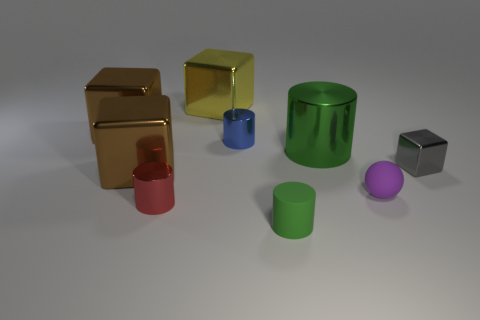There is a blue cylinder that is the same size as the gray object; what material is it?
Provide a short and direct response. Metal. There is a thing that is to the left of the tiny red cylinder and in front of the blue metal cylinder; what shape is it?
Keep it short and to the point. Cube. What color is the matte thing that is the same size as the rubber ball?
Your answer should be very brief. Green. Does the metal object that is right of the tiny purple ball have the same size as the brown metal cube that is in front of the blue cylinder?
Keep it short and to the point. No. What is the size of the shiny cube that is behind the brown cube behind the cylinder that is behind the green metal thing?
Keep it short and to the point. Large. What shape is the brown object right of the big brown object behind the small blue shiny thing?
Give a very brief answer. Cube. There is a cylinder in front of the red cylinder; does it have the same color as the large metal cylinder?
Ensure brevity in your answer.  Yes. What color is the thing that is in front of the small purple ball and on the left side of the blue cylinder?
Your answer should be very brief. Red. Are there any tiny things that have the same material as the large yellow object?
Your response must be concise. Yes. The yellow cube is what size?
Keep it short and to the point. Large. 